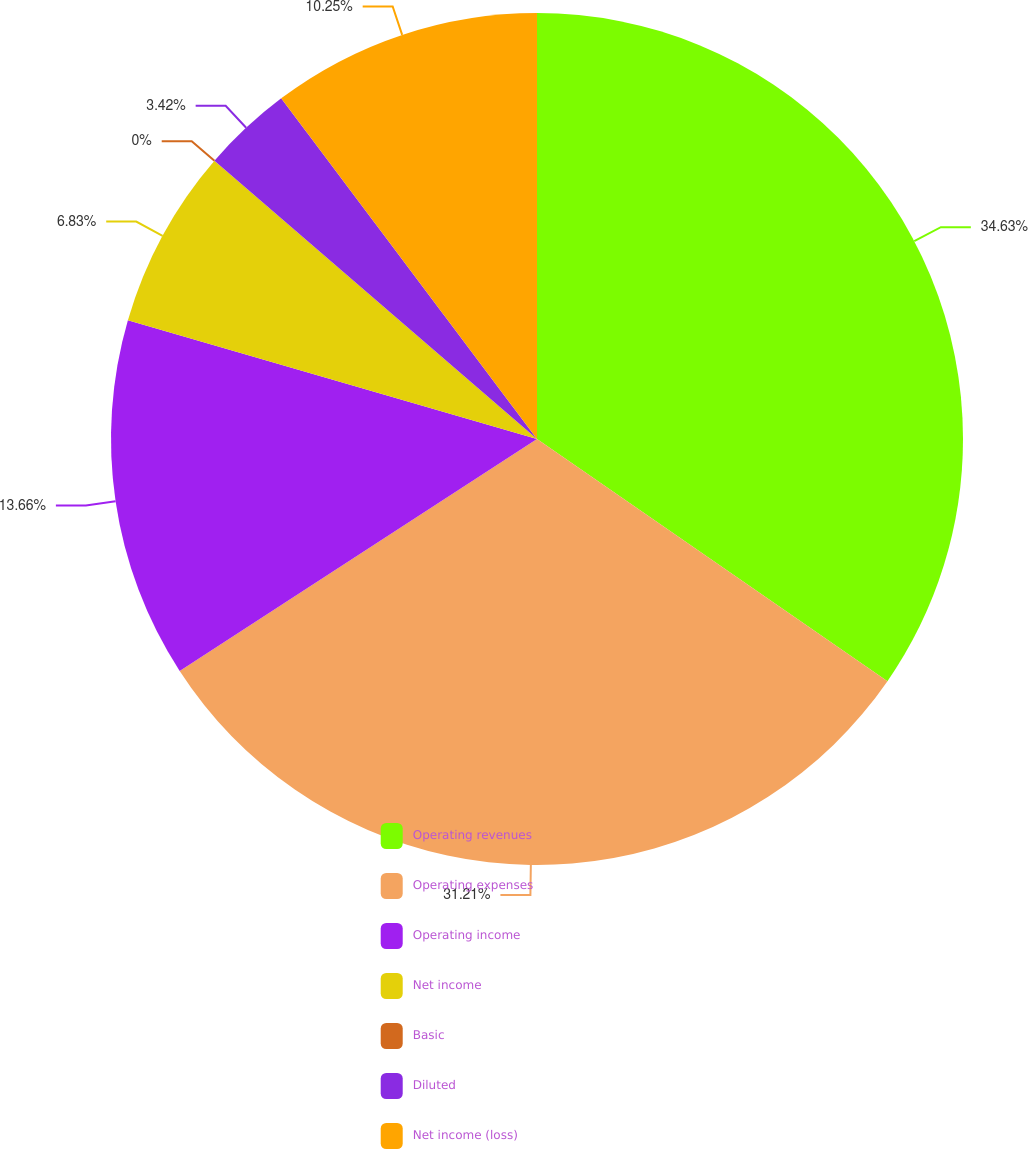<chart> <loc_0><loc_0><loc_500><loc_500><pie_chart><fcel>Operating revenues<fcel>Operating expenses<fcel>Operating income<fcel>Net income<fcel>Basic<fcel>Diluted<fcel>Net income (loss)<nl><fcel>34.62%<fcel>31.21%<fcel>13.66%<fcel>6.83%<fcel>0.0%<fcel>3.42%<fcel>10.25%<nl></chart> 